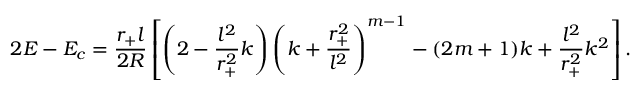Convert formula to latex. <formula><loc_0><loc_0><loc_500><loc_500>2 E - E _ { c } = \frac { r _ { + } l } { 2 R } \left [ \left ( 2 - \frac { l ^ { 2 } } { r _ { + } ^ { 2 } } k \right ) \left ( k + \frac { r _ { + } ^ { 2 } } { l ^ { 2 } } \right ) ^ { m - 1 } - ( 2 m + 1 ) k + \frac { l ^ { 2 } } { r _ { + } ^ { 2 } } k ^ { 2 } \right ] .</formula> 